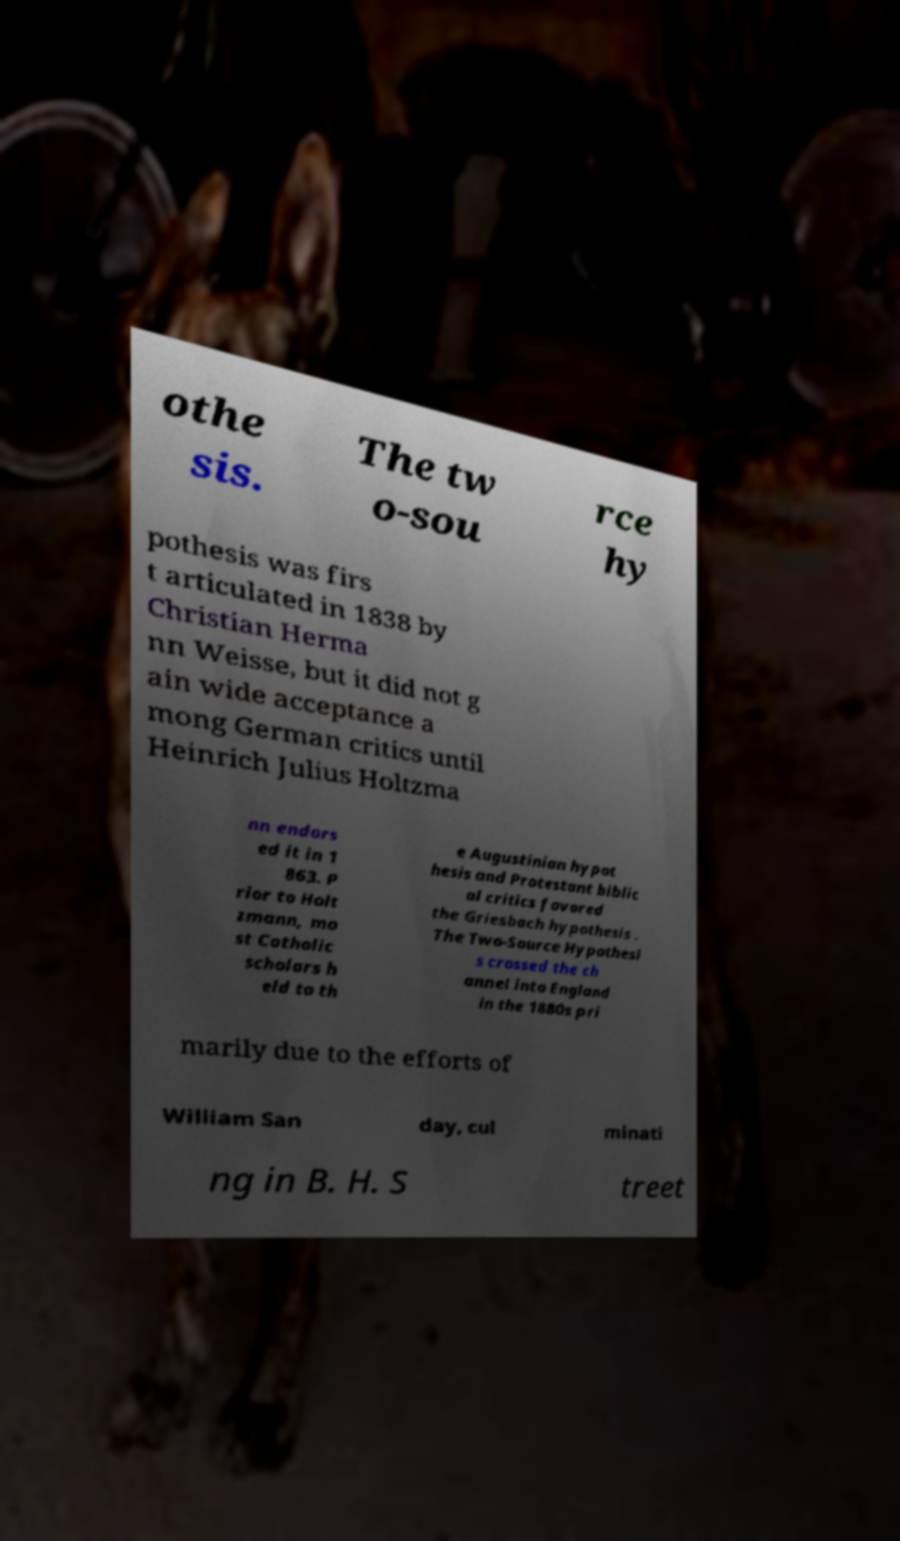Could you extract and type out the text from this image? othe sis. The tw o-sou rce hy pothesis was firs t articulated in 1838 by Christian Herma nn Weisse, but it did not g ain wide acceptance a mong German critics until Heinrich Julius Holtzma nn endors ed it in 1 863. P rior to Holt zmann, mo st Catholic scholars h eld to th e Augustinian hypot hesis and Protestant biblic al critics favored the Griesbach hypothesis . The Two-Source Hypothesi s crossed the ch annel into England in the 1880s pri marily due to the efforts of William San day, cul minati ng in B. H. S treet 